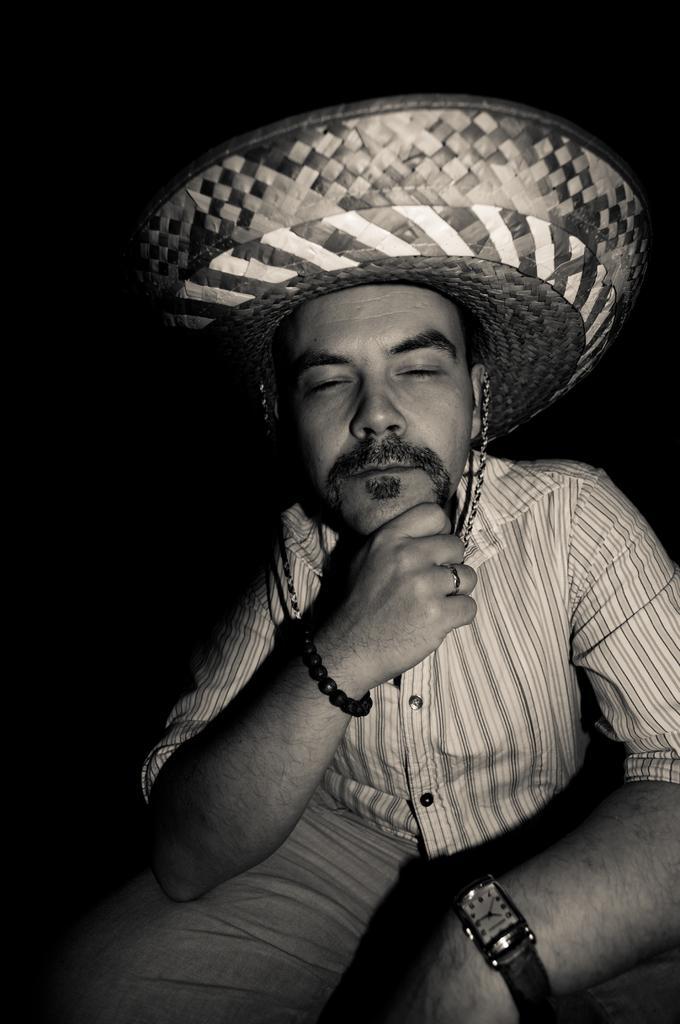Can you describe this image briefly? In this image I can see a person wearing a hat and background is dark. 